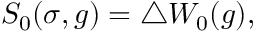<formula> <loc_0><loc_0><loc_500><loc_500>S _ { 0 } ( \sigma , g ) = \triangle W _ { 0 } ( g ) ,</formula> 